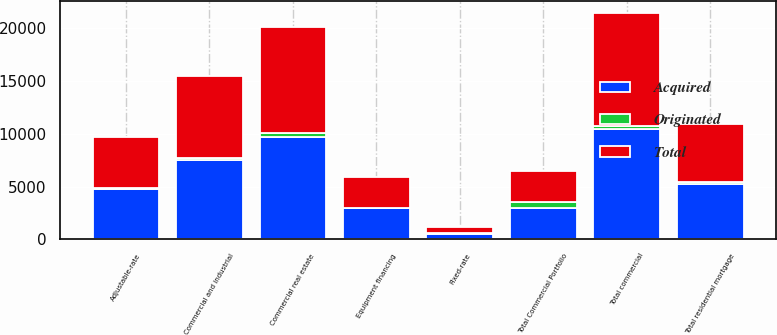Convert chart to OTSL. <chart><loc_0><loc_0><loc_500><loc_500><stacked_bar_chart><ecel><fcel>Commercial real estate<fcel>Commercial and industrial<fcel>Equipment financing<fcel>Total commercial<fcel>Total Commercial Portfolio<fcel>Adjustable-rate<fcel>Fixed-rate<fcel>Total residential mortgage<nl><fcel>Acquired<fcel>9696.9<fcel>7526.4<fcel>2957.6<fcel>10484<fcel>2965.45<fcel>4733.3<fcel>536.1<fcel>5269.4<nl><fcel>Originated<fcel>331.9<fcel>222.3<fcel>15.7<fcel>238<fcel>569.9<fcel>117.9<fcel>69.7<fcel>187.6<nl><fcel>Total<fcel>10028.8<fcel>7748.7<fcel>2973.3<fcel>10722<fcel>2965.45<fcel>4851.2<fcel>605.8<fcel>5457<nl></chart> 